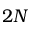Convert formula to latex. <formula><loc_0><loc_0><loc_500><loc_500>2 N</formula> 